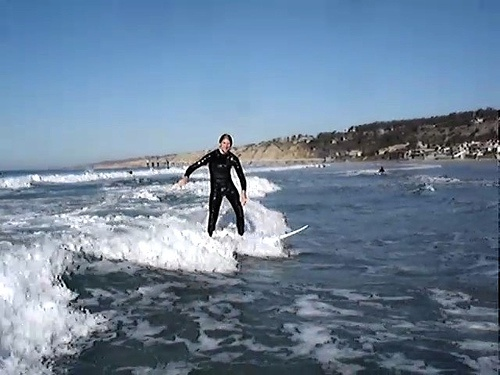Describe the objects in this image and their specific colors. I can see people in gray, black, lightgray, and darkgray tones, surfboard in gray, white, blue, and darkgray tones, people in gray, black, and darkgray tones, and people in black and gray tones in this image. 